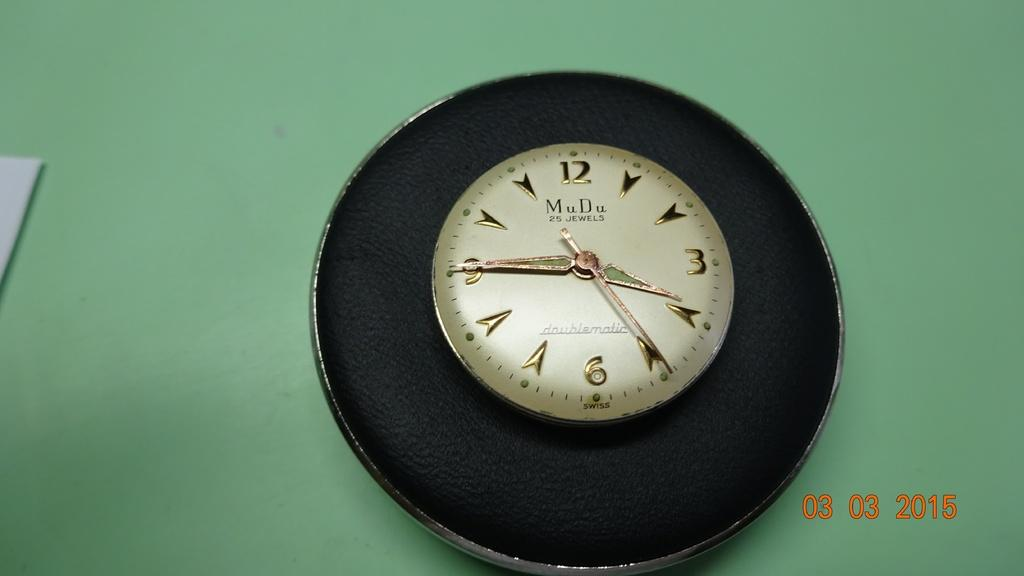Provide a one-sentence caption for the provided image. A photo taken on March 3rd of 2015. 